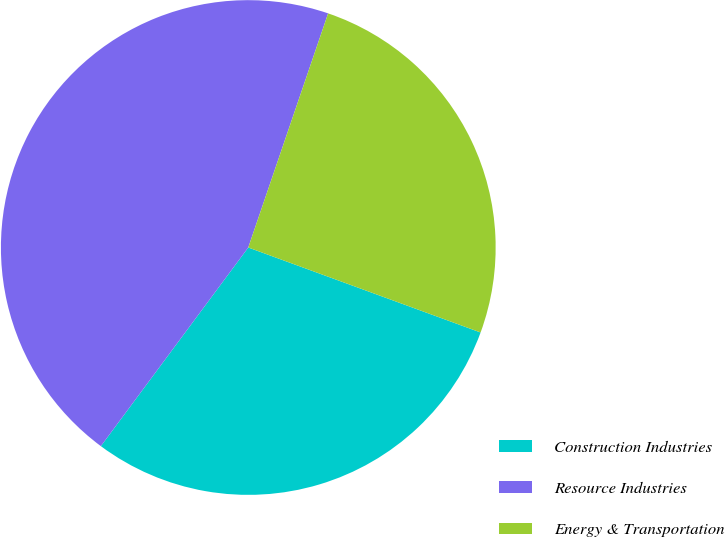<chart> <loc_0><loc_0><loc_500><loc_500><pie_chart><fcel>Construction Industries<fcel>Resource Industries<fcel>Energy & Transportation<nl><fcel>29.58%<fcel>45.07%<fcel>25.35%<nl></chart> 